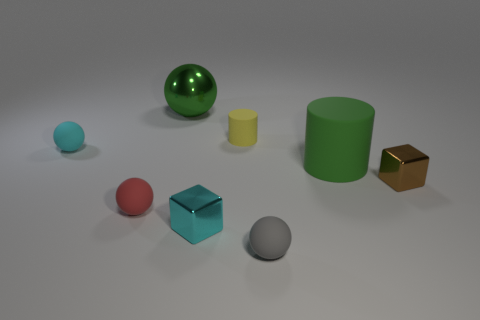The green rubber cylinder has what size? The green rubber cylinder in the image appears to be medium-sized in comparison with the other objects present, suggesting it might be roughly the size of a large mug or a small vase. 